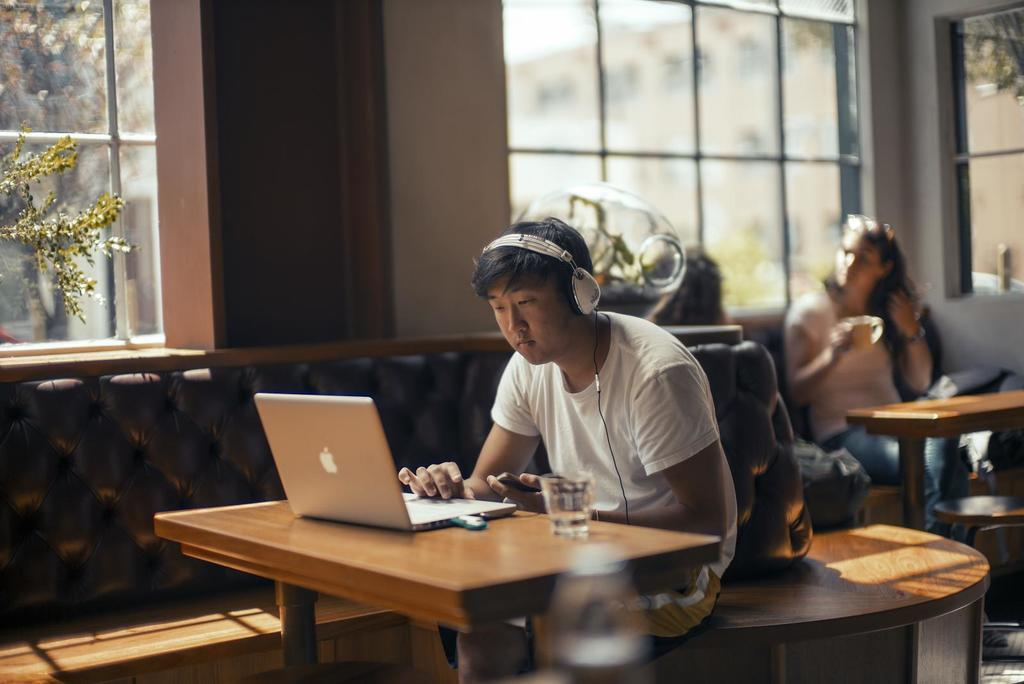What is the man in the coffee shop doing? The man is sitting and working on his laptop. What is the man wearing while working on his laptop? The man is wearing headphones. What is the man holding in his left hand? The man is holding a mobile phone in his left hand. What are the two women behind the man doing? The women are talking to each other. What type of skin is visible on the man's hand in the image? There is no specific detail about the man's skin in the image, so it cannot be determined. 